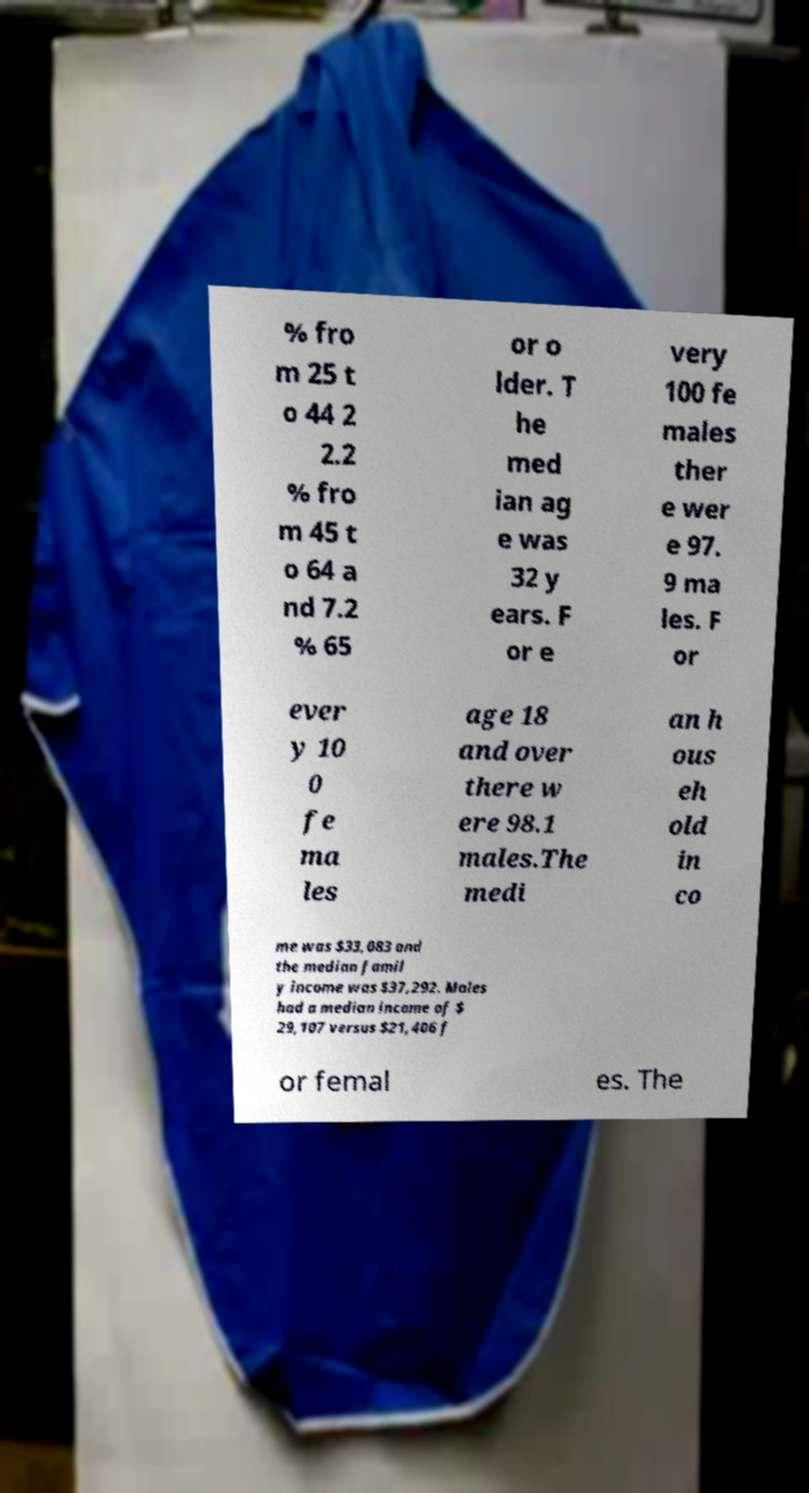There's text embedded in this image that I need extracted. Can you transcribe it verbatim? % fro m 25 t o 44 2 2.2 % fro m 45 t o 64 a nd 7.2 % 65 or o lder. T he med ian ag e was 32 y ears. F or e very 100 fe males ther e wer e 97. 9 ma les. F or ever y 10 0 fe ma les age 18 and over there w ere 98.1 males.The medi an h ous eh old in co me was $33,083 and the median famil y income was $37,292. Males had a median income of $ 29,107 versus $21,406 f or femal es. The 